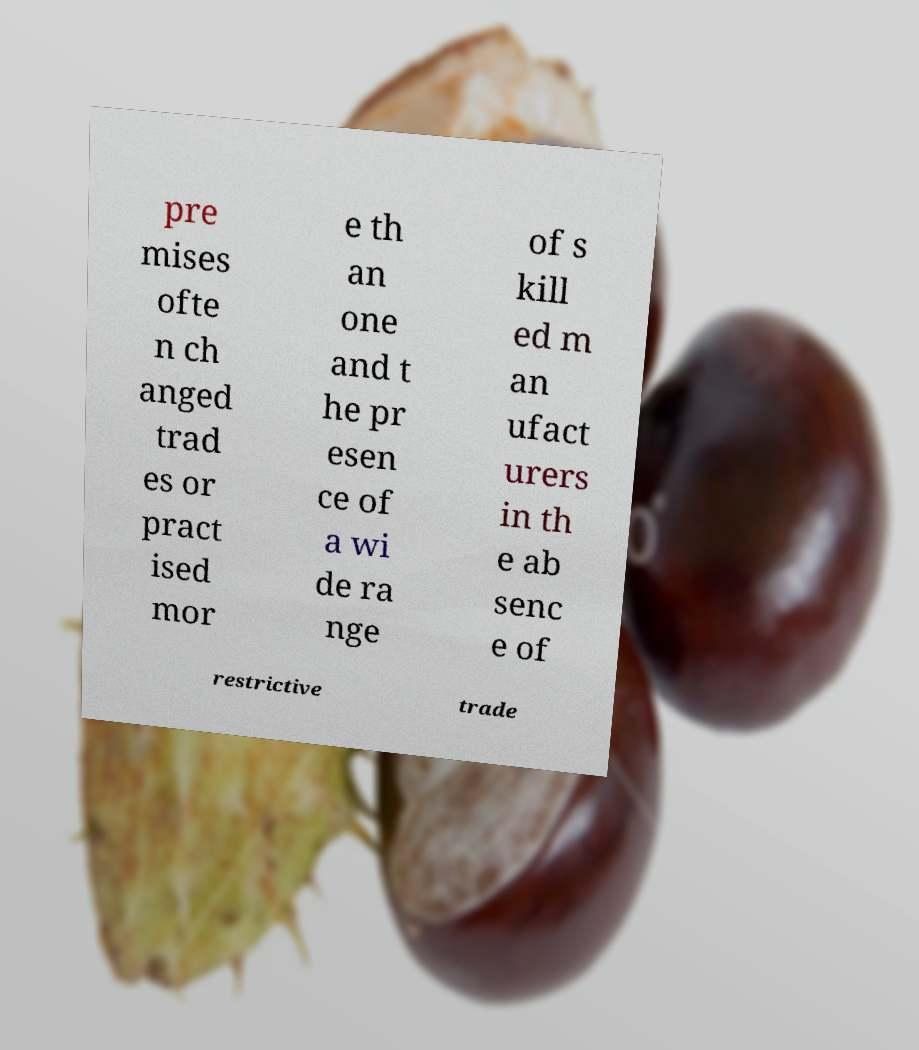Could you extract and type out the text from this image? pre mises ofte n ch anged trad es or pract ised mor e th an one and t he pr esen ce of a wi de ra nge of s kill ed m an ufact urers in th e ab senc e of restrictive trade 